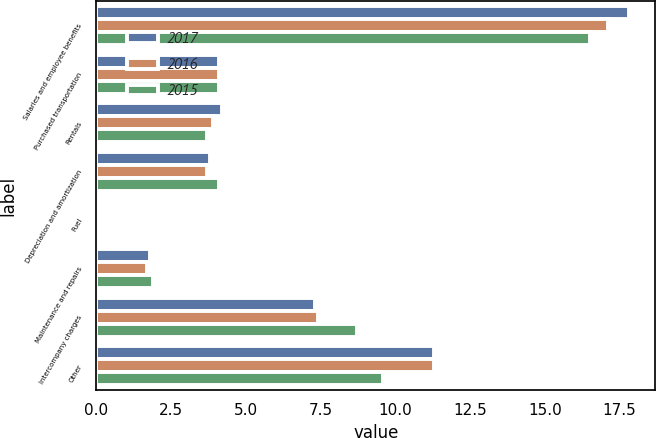Convert chart. <chart><loc_0><loc_0><loc_500><loc_500><stacked_bar_chart><ecel><fcel>Salaries and employee benefits<fcel>Purchased transportation<fcel>Rentals<fcel>Depreciation and amortization<fcel>Fuel<fcel>Maintenance and repairs<fcel>Intercompany charges<fcel>Other<nl><fcel>2017<fcel>17.8<fcel>4.1<fcel>4.2<fcel>3.8<fcel>0.1<fcel>1.8<fcel>7.3<fcel>11.3<nl><fcel>2016<fcel>17.1<fcel>4.1<fcel>3.9<fcel>3.7<fcel>0.1<fcel>1.7<fcel>7.4<fcel>11.3<nl><fcel>2015<fcel>16.5<fcel>4.1<fcel>3.7<fcel>4.1<fcel>0.1<fcel>1.9<fcel>8.7<fcel>9.6<nl></chart> 